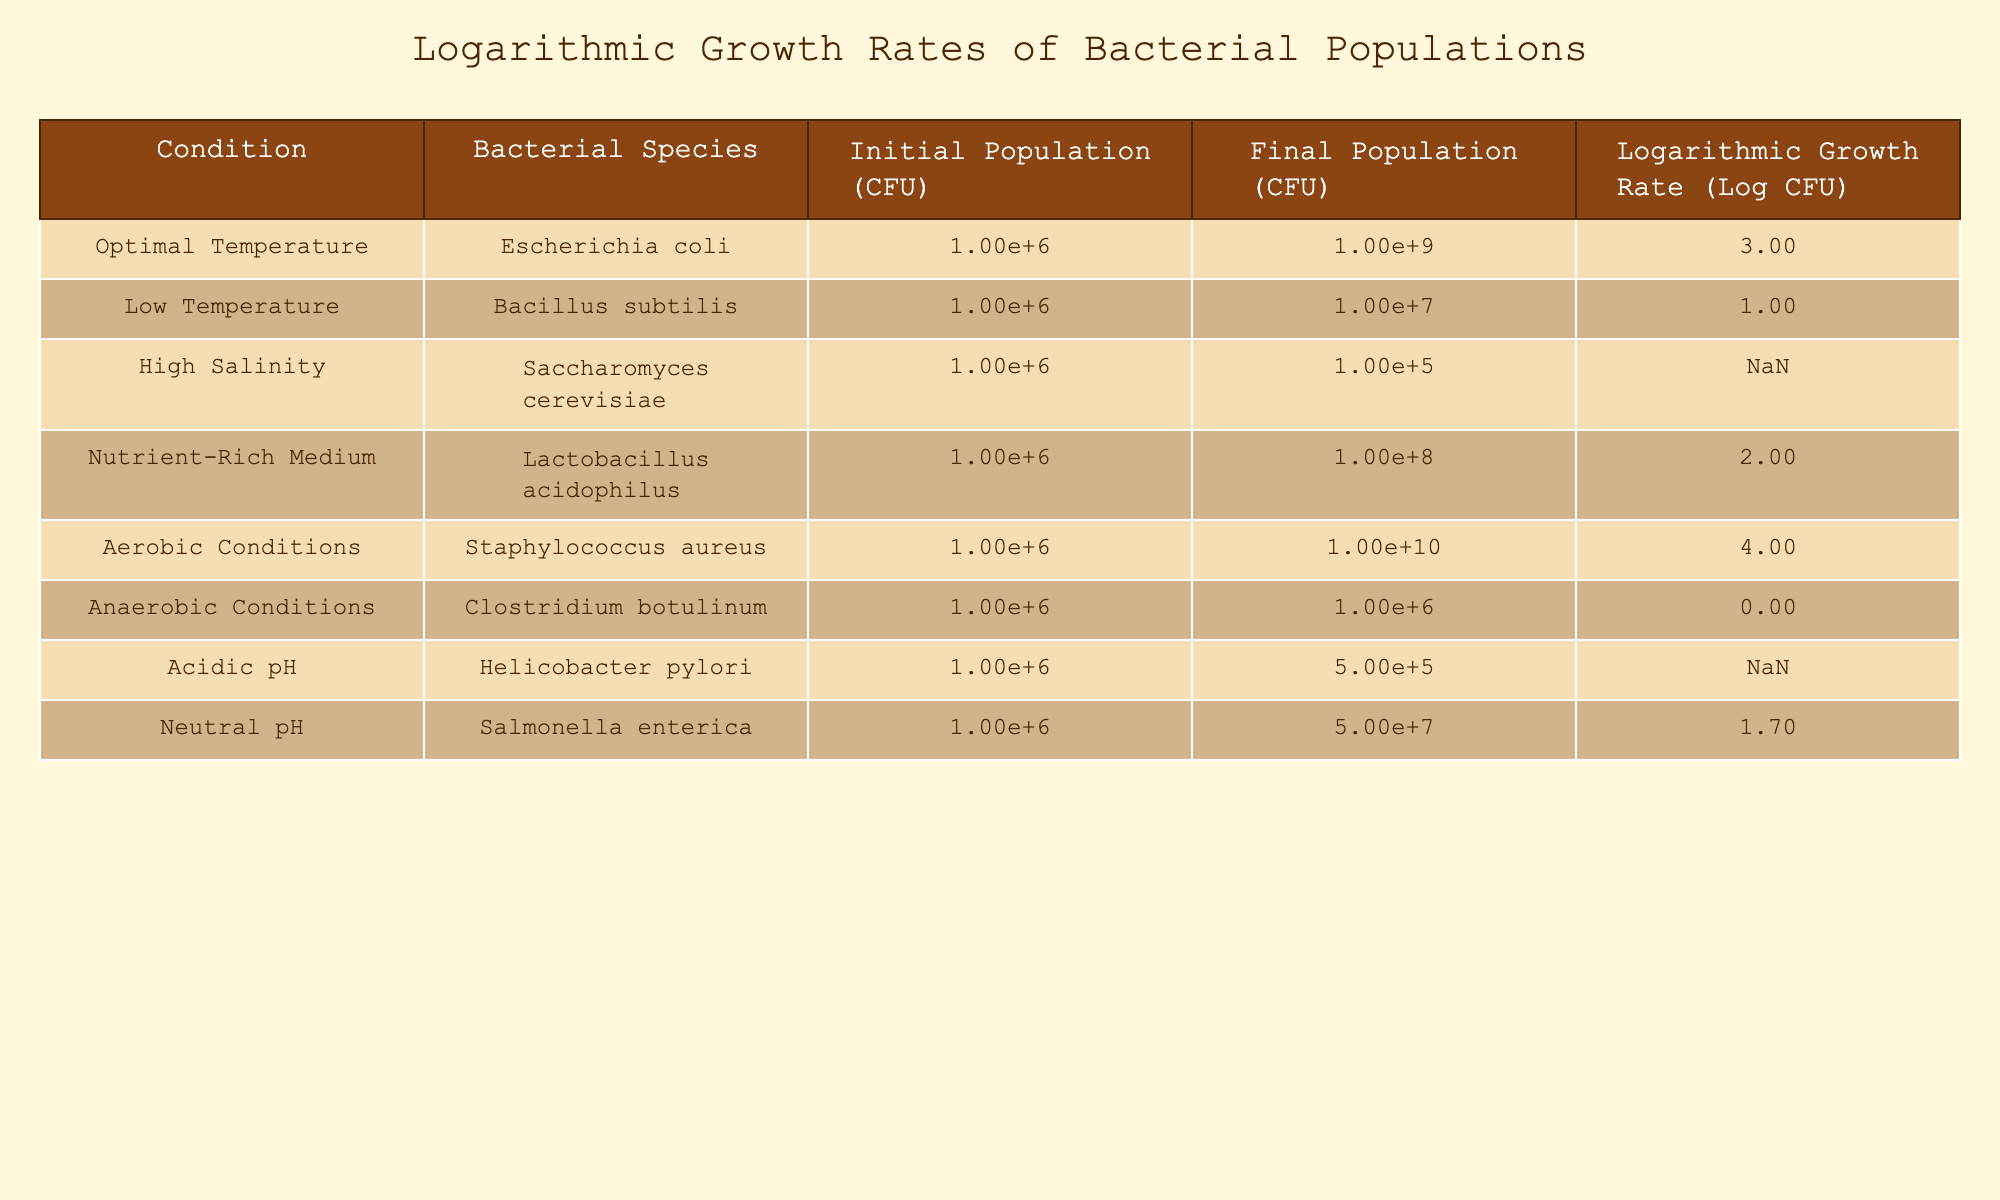What is the logarithmic growth rate for Escherichia coli under optimal temperature? The table shows that the logarithmic growth rate for Escherichia coli under optimal temperature is listed as 3.0.
Answer: 3.0 Which bacterial species exhibited a population decrease due to high salinity? The table indicates that the logarithmic growth rate for Saccharomyces cerevisiae under high salinity is (-0.5), showing a decrease in population, since negative growth rates imply a decline.
Answer: Saccharomyces cerevisiae What is the average logarithmic growth rate for all conditions listed? The logarithmic growth rates from the table are 3.0, 1.0, -0.5, 2.0, 4.0, 0.0, -0.3, and 1.7. Summing these gives 11.9 and dividing by 8 (the number of conditions) results in an average of approximately 1.49.
Answer: 1.49 Is Lactobacillus acidophilus growing faster in nutrient-rich medium compared to Bacillus subtilis in low temperature? The logarithmic growth rate for Lactobacillus acidophilus in nutrient-rich medium is 2.0, while for Bacillus subtilis in low temperature it is 1.0. Therefore, Lactobacillus acidophilus is growing faster because 2.0 > 1.0.
Answer: Yes What is the difference in logarithmic growth rate between aerobic conditions and anaerobic conditions? The logarithmic growth rate for Staphylococcus aureus under aerobic conditions is 4.0, and for Clostridium botulinum under anaerobic conditions, it is 0.0. The difference is 4.0 - 0.0 = 4.0, meaning aerobic conditions provide a significantly higher growth rate.
Answer: 4.0 